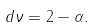<formula> <loc_0><loc_0><loc_500><loc_500>d \nu = 2 - \alpha .</formula> 